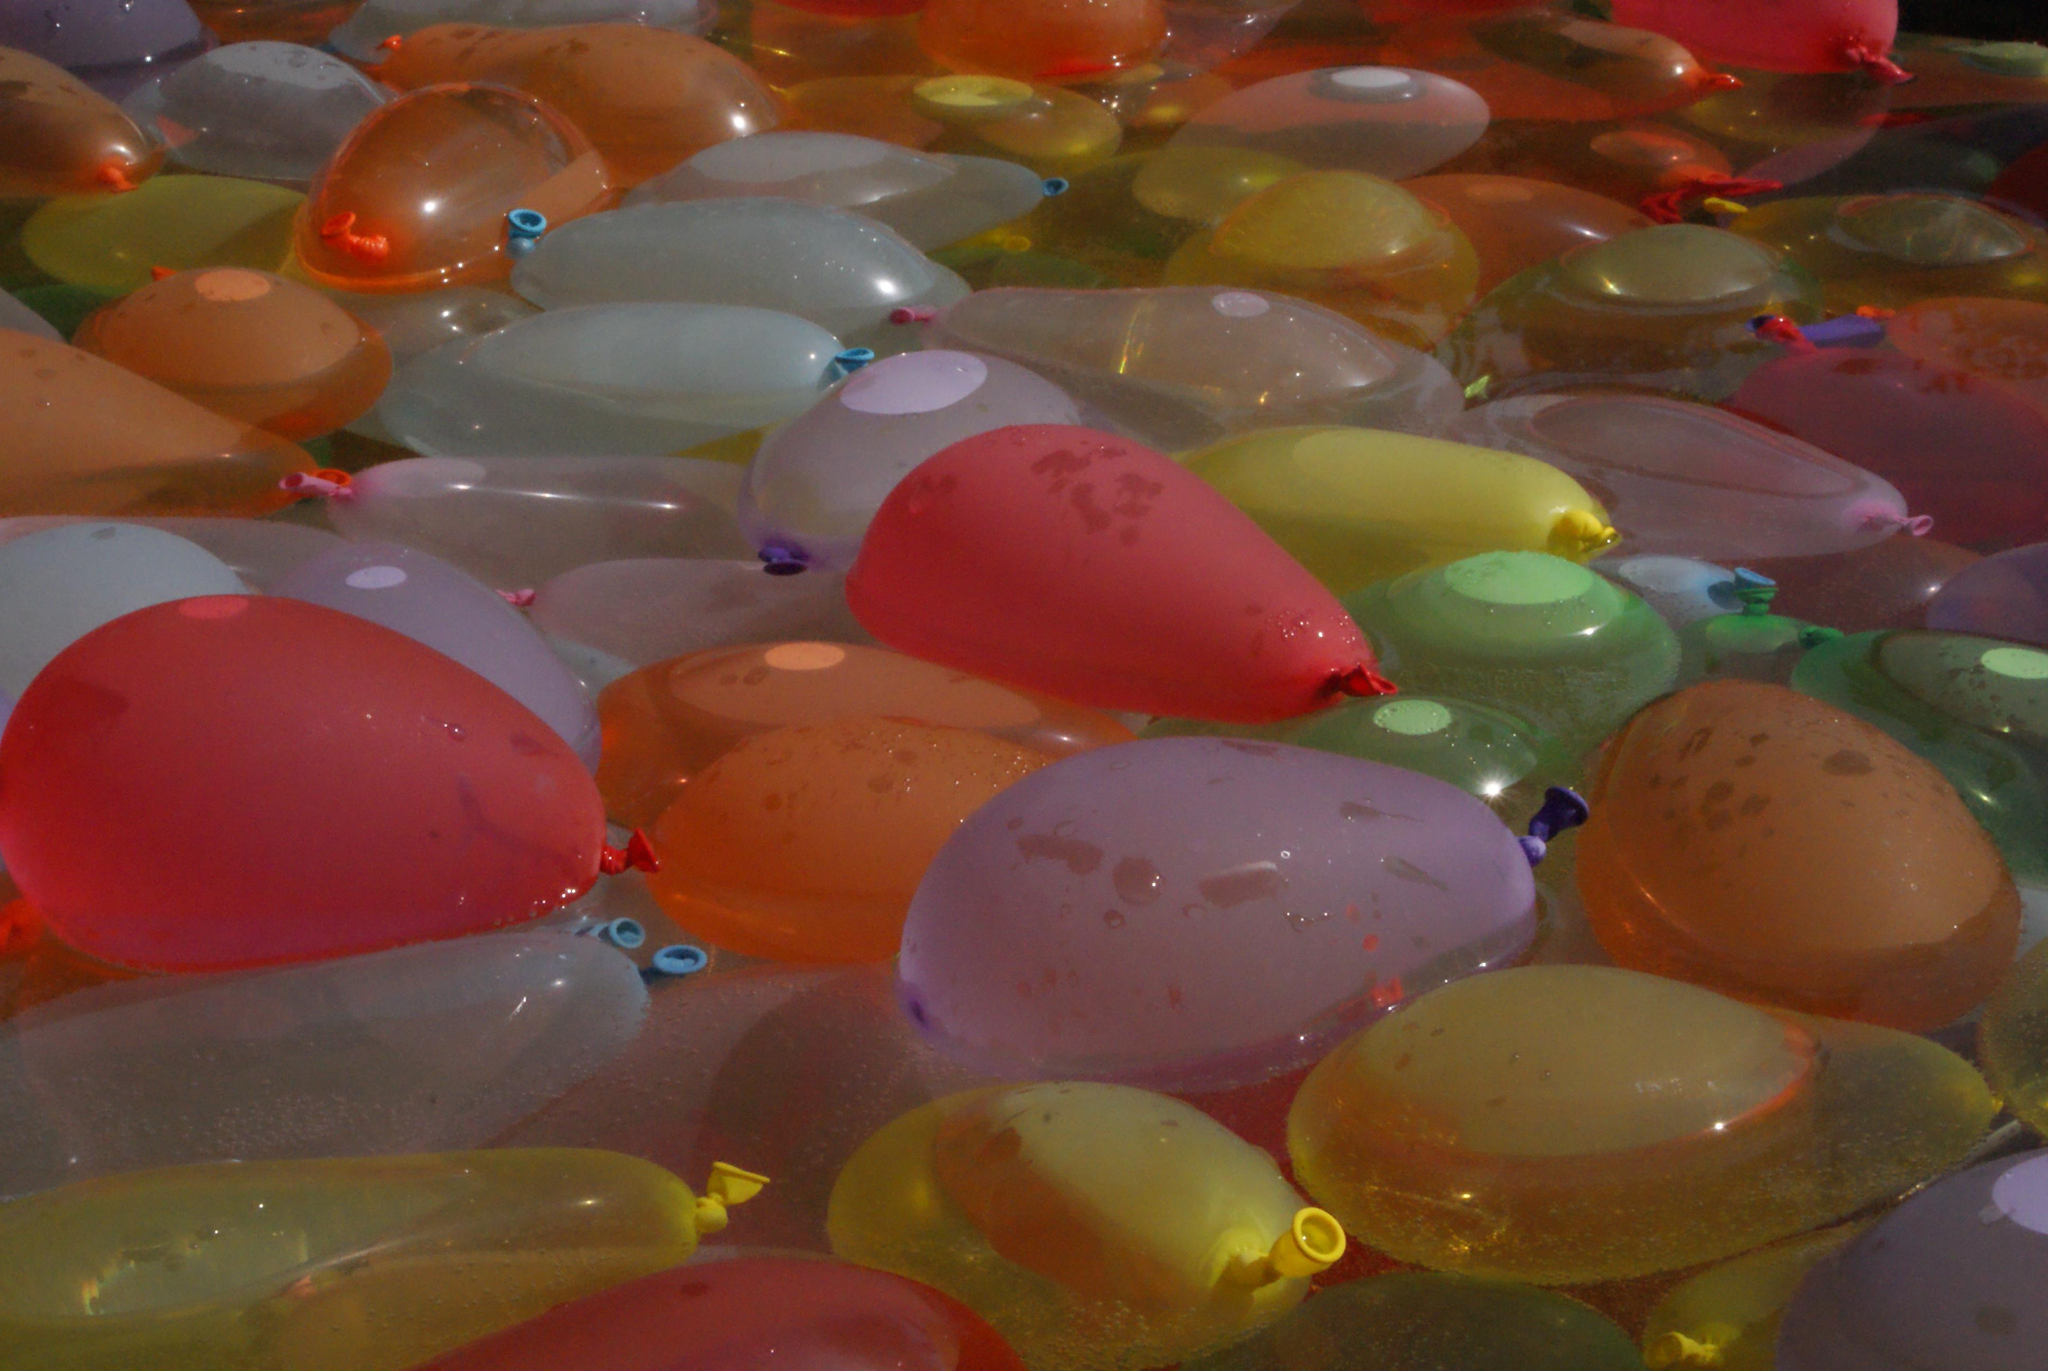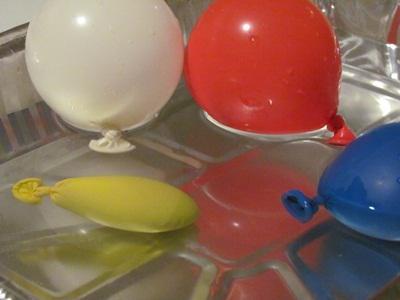The first image is the image on the left, the second image is the image on the right. Given the left and right images, does the statement "Some balloons have helium in them." hold true? Answer yes or no. No. The first image is the image on the left, the second image is the image on the right. Examine the images to the left and right. Is the description "Several balloons are in the air in the left image, and at least a dozen balloons are in a container with sides in the right image." accurate? Answer yes or no. No. 